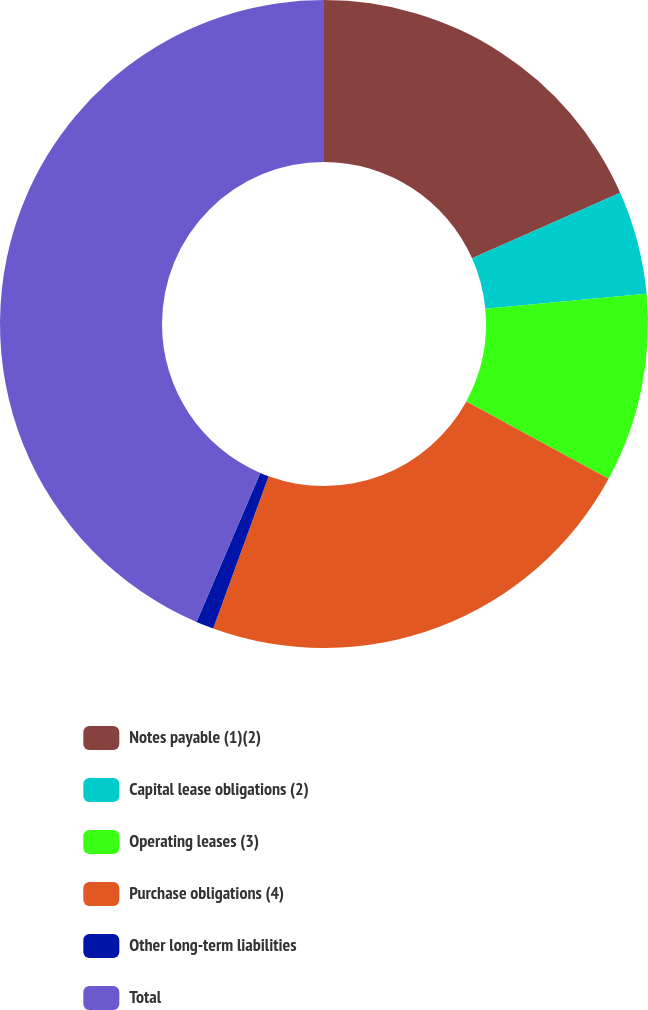Convert chart to OTSL. <chart><loc_0><loc_0><loc_500><loc_500><pie_chart><fcel>Notes payable (1)(2)<fcel>Capital lease obligations (2)<fcel>Operating leases (3)<fcel>Purchase obligations (4)<fcel>Other long-term liabilities<fcel>Total<nl><fcel>18.36%<fcel>5.15%<fcel>9.42%<fcel>22.63%<fcel>0.88%<fcel>43.57%<nl></chart> 